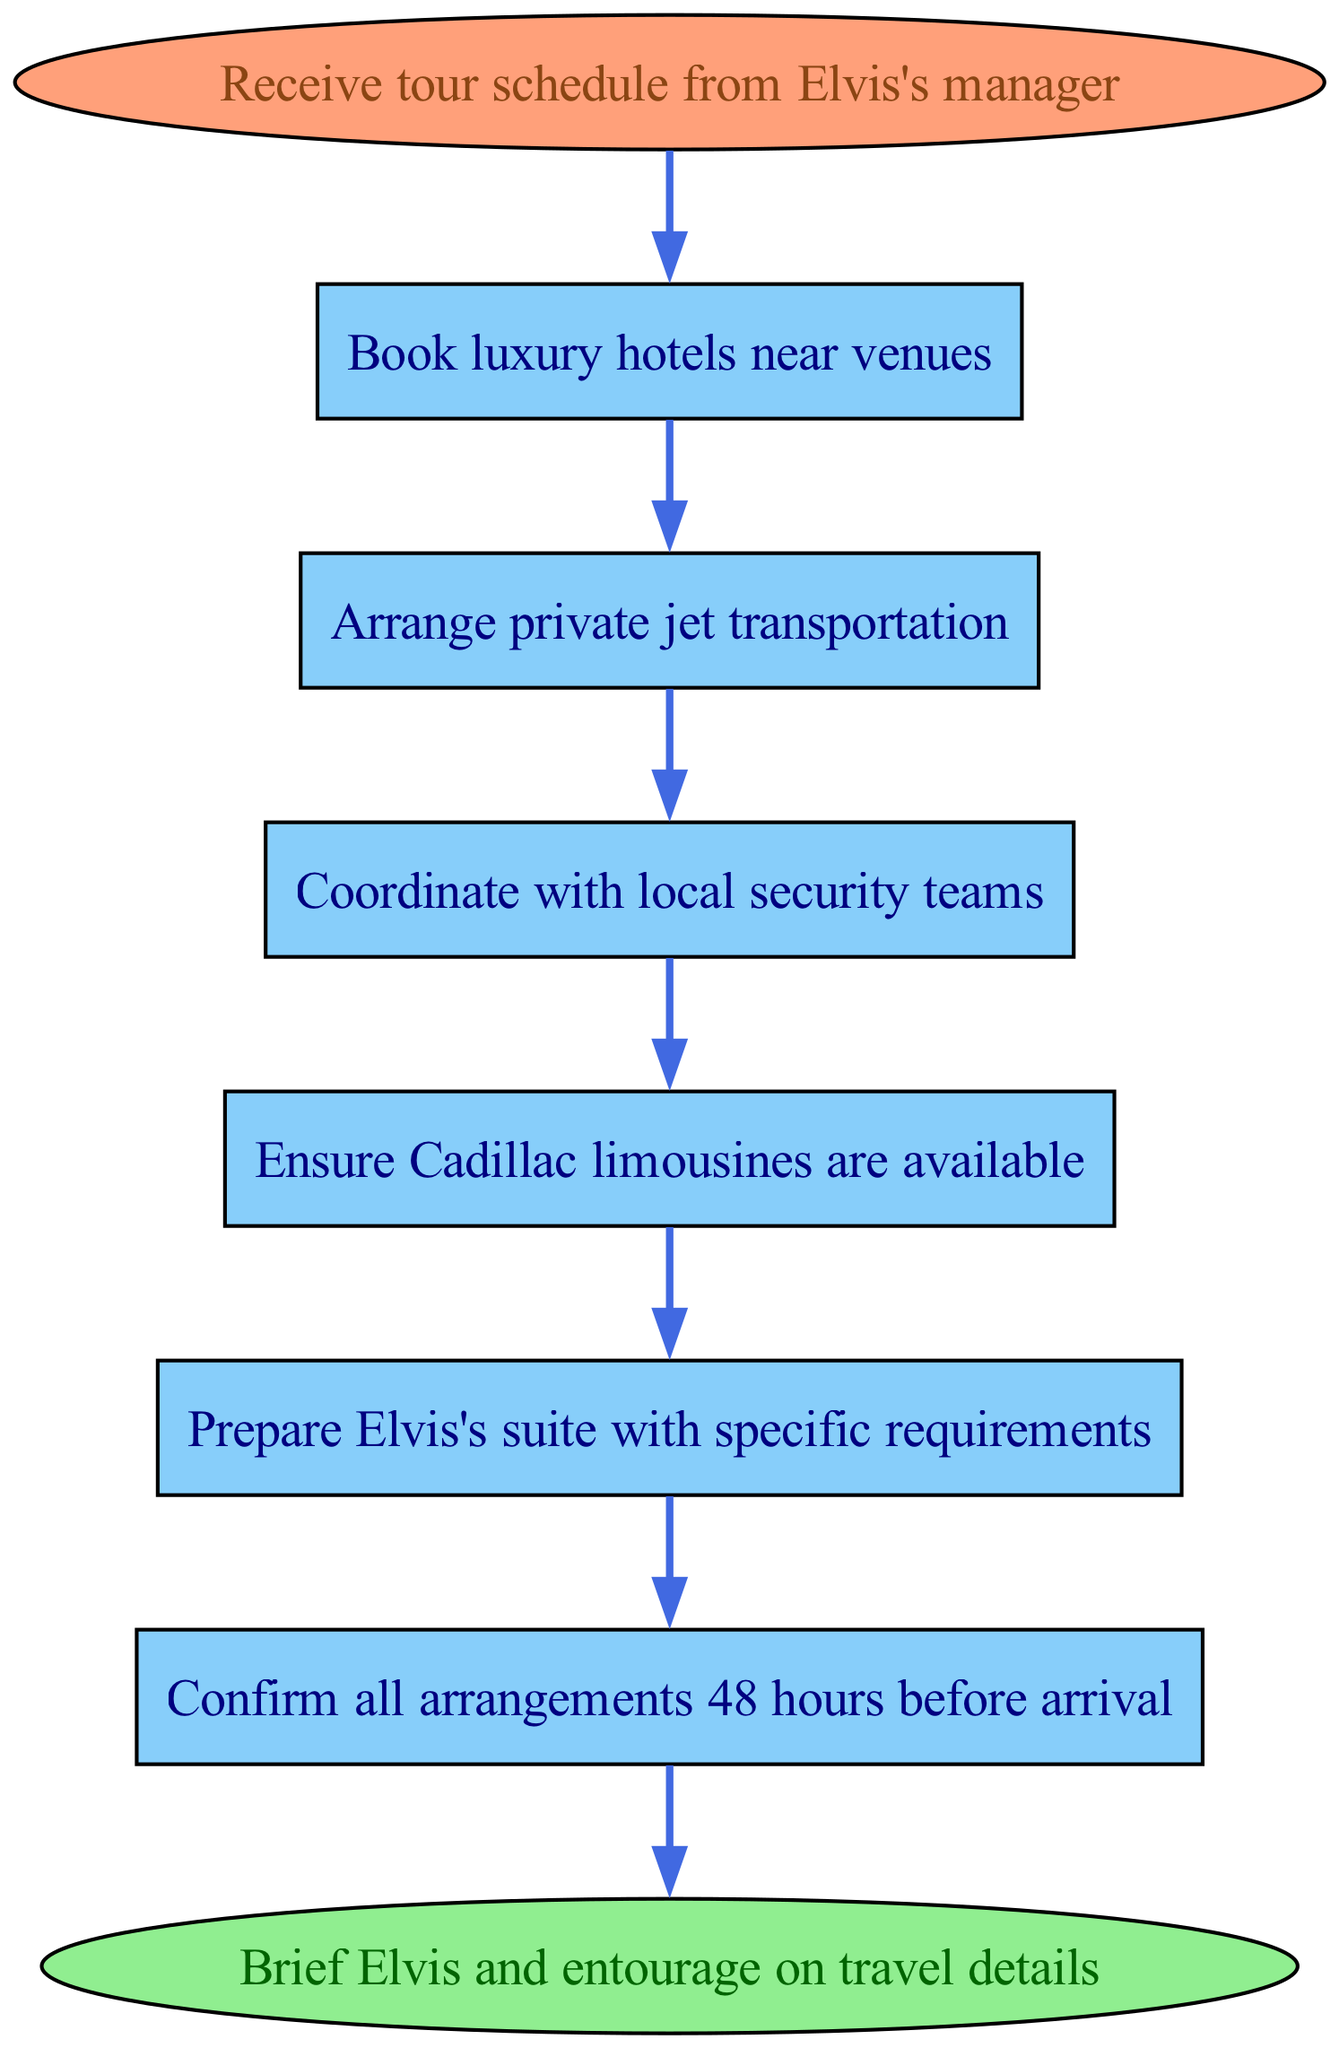What is the first step in managing the travel arrangements? The first step is to "Receive tour schedule from Elvis's manager." This is the starting point of the flow chart where the entire process begins.
Answer: Receive tour schedule from Elvis's manager How many steps are there in total? The flow chart contains a total of 6 steps (excluding the start and end nodes). Each individually numbered step represents a process in the arrangements.
Answer: 6 What is the last step before briefing Elvis? The last step before briefing Elvis and the entourage is to "Confirm all arrangements 48 hours before arrival." This is the final check to ensure everything is set in place.
Answer: Confirm all arrangements 48 hours before arrival What needs to be arranged after booking hotels? After booking luxury hotels near venues, the next step is to "Arrange private jet transportation." This indicates the sequence of operations necessary for travel planning.
Answer: Arrange private jet transportation Which step includes ensuring vehicle availability? Ensuring vehicle availability is mentioned in the step "Ensure Cadillac limousines are available." This step focuses on having transportation ready for Elvis's travel needs.
Answer: Ensure Cadillac limousines are available Which two steps directly follow arranging private jet transportation? The two steps that directly follow arranging private jet transportation are "Coordinate with local security teams" and "Ensure Cadillac limousines are available." This reflects the interconnected nature of travel and security arrangements.
Answer: Coordinate with local security teams, Ensure Cadillac limousines are available What color are the process nodes in the diagram? The process nodes in the diagram are colored '#87CEFA', which is a light blue shade. This color differentiates them from the start and end nodes, which have different colors.
Answer: Light blue What action is taken 48 hours prior to arrival? The action taken 48 hours before arrival is to "Confirm all arrangements." This critical step ensures that all prior preparatory steps have been completed satisfactorily.
Answer: Confirm all arrangements What is the main purpose of this flow chart? The main purpose of this flow chart is to outline the sequential process of "Managing Elvis's travel and accommodation arrangements." Each step plays a vital role in the overall management task.
Answer: Managing Elvis's travel and accommodation arrangements 